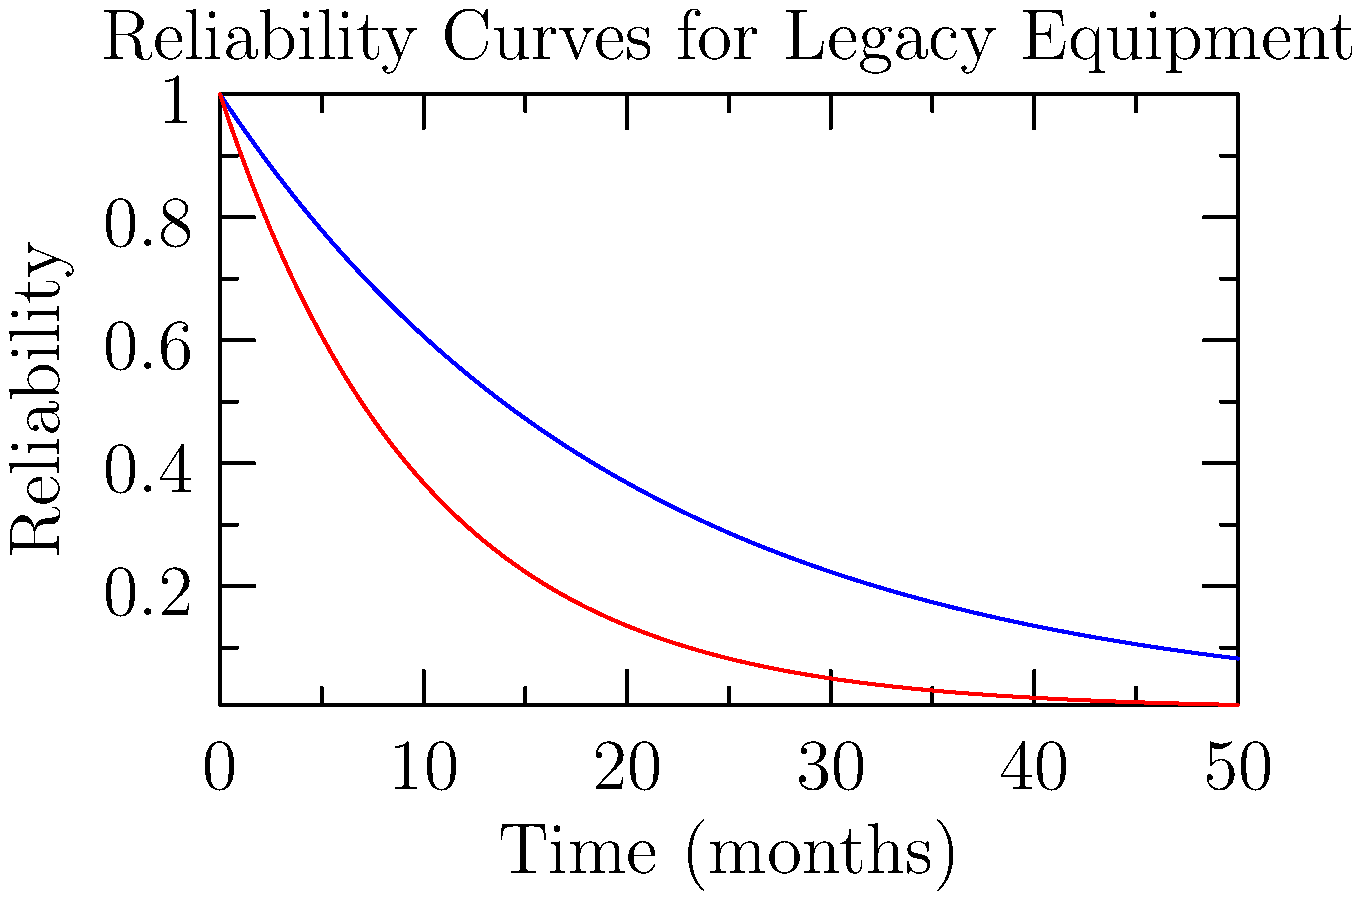As a product manager overseeing legacy industrial equipment, you're tasked with optimizing the maintenance schedule. The graph shows reliability curves for two pieces of equipment, A and B. If the minimum acceptable reliability is 0.7, and you want to minimize maintenance frequency while ensuring both pieces of equipment meet this threshold, how often (in months) should maintenance be performed? To solve this problem, we need to follow these steps:

1. Understand the reliability curves:
   - Equipment A (blue curve): $R_A(t) = e^{-0.05t}$
   - Equipment B (red curve): $R_B(t) = e^{-0.1t}$

2. Set the minimum acceptable reliability:
   $R_{min} = 0.7$

3. Find the time at which each equipment reaches the minimum reliability:
   For Equipment A: $0.7 = e^{-0.05t_A}$
   $\ln(0.7) = -0.05t_A$
   $t_A = -\frac{\ln(0.7)}{0.05} \approx 7.13$ months

   For Equipment B: $0.7 = e^{-0.1t_B}$
   $\ln(0.7) = -0.1t_B$
   $t_B = -\frac{\ln(0.7)}{0.1} \approx 3.57$ months

4. Choose the shorter time to ensure both pieces of equipment meet the threshold:
   $t_{maintenance} = \min(t_A, t_B) \approx 3.57$ months

5. Round down to the nearest whole number of months for practical implementation:
   $t_{maintenance} = 3$ months
Answer: 3 months 